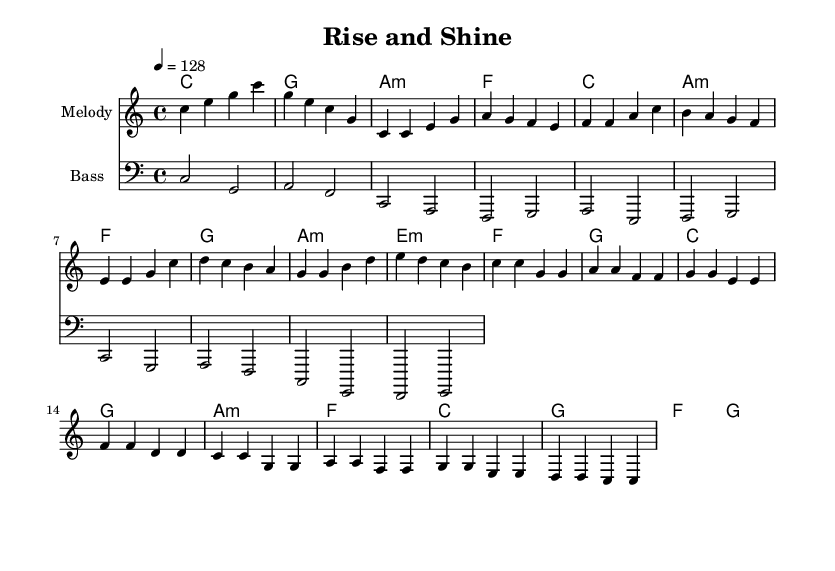What is the key signature of this music? The key signature is C major, which has no sharps or flats.
Answer: C major What is the time signature of this music? The time signature is indicated at the beginning as 4/4, meaning there are four beats per measure.
Answer: 4/4 What is the tempo marking for this piece? The tempo marking indicates that the piece should be played at a speed of 128 beats per minute.
Answer: 128 How many measures are in the chorus section? By analyzing the chorus lines presented, there are four measures noted, indicating the length of the chorus.
Answer: 4 What are the first two chords in the intro? The first two chords listed in the harmonies section under the intro are C major and G major, respectively.
Answer: C, G Which section follows the verse in the structure? The structure indicates that the pre-chorus follows the verse, as seen in the order of the melody and harmonies.
Answer: Pre-Chorus What is the primary mood conveyed by this piece based on its tempo and key? The combination of an upbeat tempo and a major key typically conveys a positive and motivational mood, ideal for morning commutes and workouts.
Answer: Upbeat 